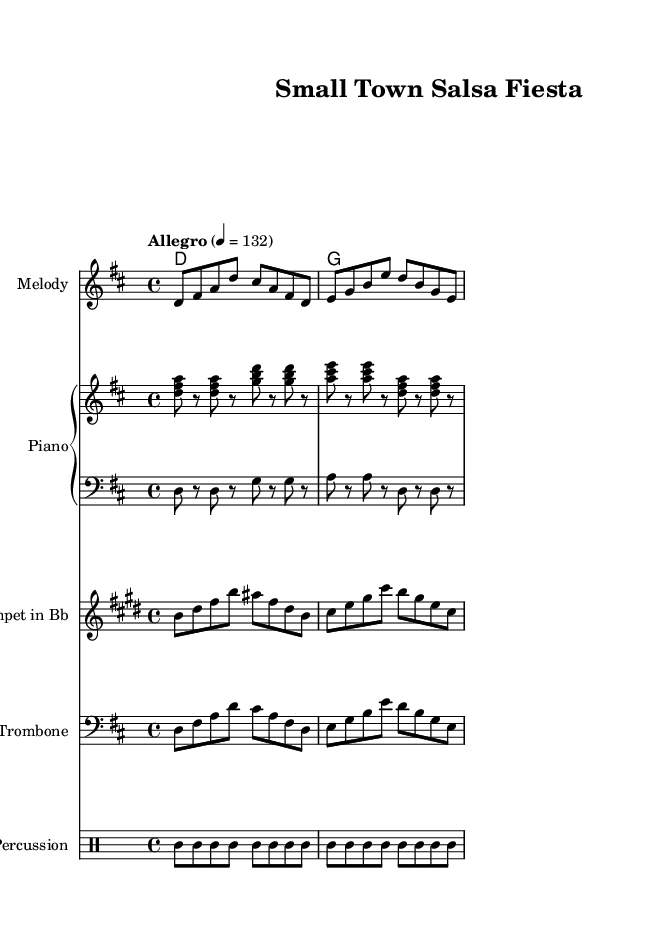What is the key signature of this music? The key signature indicates the tonal center of the piece, which is D major, as denoted by the two sharps (F# and C#).
Answer: D major What is the time signature of this music? The time signature tells us how many beats are in each measure. Here, it is 4/4, meaning there are four beats per measure and a quarter note gets one beat.
Answer: 4/4 What is the tempo marking specified in the sheet music? The tempo marking is vital as it gives the speed of the piece. In this case, it is "Allegro," which indicates a brisk pace, further specified by "4 = 132," meaning there are 132 beats per minute.
Answer: Allegro, 4 = 132 How many measures are in the melody section? Counting the measures in the melody part, there are four measures, each showcasing distinct musical phrases that support the upbeat, celebratory nature of the tune.
Answer: Four Which instruments are included in this arrangement? The arrangement features multiple instruments: Melody, Piano (with right and left hand parts), Trumpet in Bb, Trombone, and Percussion. This variety captures the essence of a lively salsa tune.
Answer: Melody, Piano, Trumpet in Bb, Trombone, Percussion What is the main rhythmic figure used in the percussion section? The percussion section utilizes consistent rhythmic patterns, specifically focusing on the toms and adding accents, which are essential for the energetic feel of salsa music. The figure repeats every four measures, creating a strong rhythmic foundation.
Answer: Tom-tom rhythm 